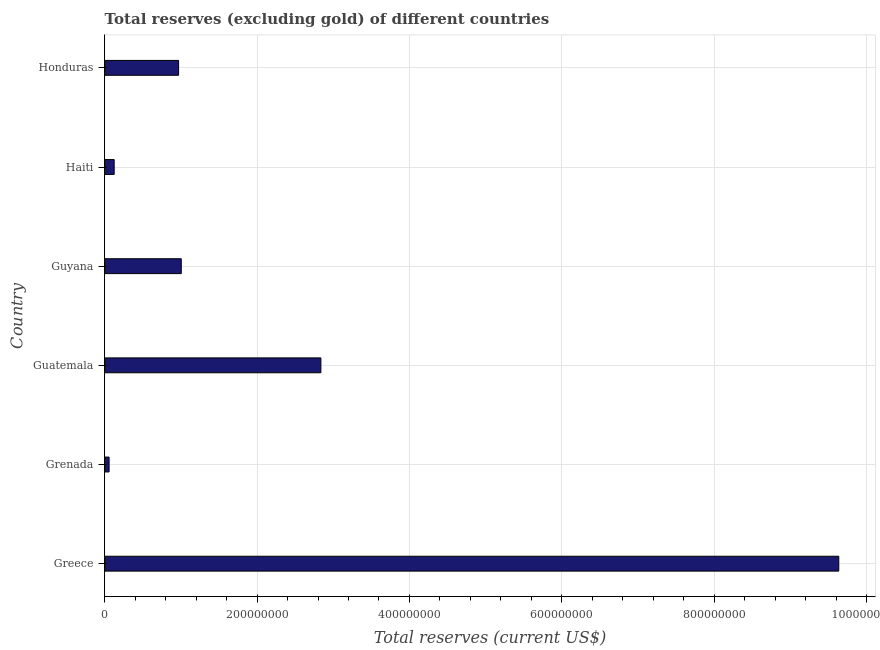Does the graph contain any zero values?
Give a very brief answer. No. Does the graph contain grids?
Make the answer very short. Yes. What is the title of the graph?
Provide a short and direct response. Total reserves (excluding gold) of different countries. What is the label or title of the X-axis?
Your answer should be compact. Total reserves (current US$). What is the total reserves (excluding gold) in Greece?
Your answer should be compact. 9.64e+08. Across all countries, what is the maximum total reserves (excluding gold)?
Make the answer very short. 9.64e+08. Across all countries, what is the minimum total reserves (excluding gold)?
Your response must be concise. 5.75e+06. In which country was the total reserves (excluding gold) maximum?
Your answer should be very brief. Greece. In which country was the total reserves (excluding gold) minimum?
Your answer should be very brief. Grenada. What is the sum of the total reserves (excluding gold)?
Keep it short and to the point. 1.46e+09. What is the difference between the total reserves (excluding gold) in Guyana and Haiti?
Ensure brevity in your answer.  8.81e+07. What is the average total reserves (excluding gold) per country?
Offer a terse response. 2.44e+08. What is the median total reserves (excluding gold)?
Your response must be concise. 9.87e+07. What is the ratio of the total reserves (excluding gold) in Guatemala to that in Guyana?
Ensure brevity in your answer.  2.82. Is the difference between the total reserves (excluding gold) in Greece and Guatemala greater than the difference between any two countries?
Provide a succinct answer. No. What is the difference between the highest and the second highest total reserves (excluding gold)?
Provide a succinct answer. 6.80e+08. What is the difference between the highest and the lowest total reserves (excluding gold)?
Your response must be concise. 9.58e+08. In how many countries, is the total reserves (excluding gold) greater than the average total reserves (excluding gold) taken over all countries?
Give a very brief answer. 2. How many bars are there?
Make the answer very short. 6. Are the values on the major ticks of X-axis written in scientific E-notation?
Offer a terse response. No. What is the Total reserves (current US$) in Greece?
Offer a very short reply. 9.64e+08. What is the Total reserves (current US$) of Grenada?
Give a very brief answer. 5.75e+06. What is the Total reserves (current US$) of Guatemala?
Your answer should be compact. 2.84e+08. What is the Total reserves (current US$) of Guyana?
Ensure brevity in your answer.  1.00e+08. What is the Total reserves (current US$) in Haiti?
Your answer should be compact. 1.24e+07. What is the Total reserves (current US$) of Honduras?
Ensure brevity in your answer.  9.70e+07. What is the difference between the Total reserves (current US$) in Greece and Grenada?
Give a very brief answer. 9.58e+08. What is the difference between the Total reserves (current US$) in Greece and Guatemala?
Your answer should be compact. 6.80e+08. What is the difference between the Total reserves (current US$) in Greece and Guyana?
Provide a succinct answer. 8.63e+08. What is the difference between the Total reserves (current US$) in Greece and Haiti?
Your response must be concise. 9.51e+08. What is the difference between the Total reserves (current US$) in Greece and Honduras?
Keep it short and to the point. 8.67e+08. What is the difference between the Total reserves (current US$) in Grenada and Guatemala?
Ensure brevity in your answer.  -2.78e+08. What is the difference between the Total reserves (current US$) in Grenada and Guyana?
Keep it short and to the point. -9.47e+07. What is the difference between the Total reserves (current US$) in Grenada and Haiti?
Keep it short and to the point. -6.68e+06. What is the difference between the Total reserves (current US$) in Grenada and Honduras?
Provide a succinct answer. -9.12e+07. What is the difference between the Total reserves (current US$) in Guatemala and Guyana?
Give a very brief answer. 1.83e+08. What is the difference between the Total reserves (current US$) in Guatemala and Haiti?
Offer a terse response. 2.71e+08. What is the difference between the Total reserves (current US$) in Guatemala and Honduras?
Provide a short and direct response. 1.87e+08. What is the difference between the Total reserves (current US$) in Guyana and Haiti?
Keep it short and to the point. 8.81e+07. What is the difference between the Total reserves (current US$) in Guyana and Honduras?
Keep it short and to the point. 3.53e+06. What is the difference between the Total reserves (current US$) in Haiti and Honduras?
Provide a succinct answer. -8.45e+07. What is the ratio of the Total reserves (current US$) in Greece to that in Grenada?
Provide a succinct answer. 167.5. What is the ratio of the Total reserves (current US$) in Greece to that in Guatemala?
Give a very brief answer. 3.4. What is the ratio of the Total reserves (current US$) in Greece to that in Guyana?
Your response must be concise. 9.59. What is the ratio of the Total reserves (current US$) in Greece to that in Haiti?
Offer a very short reply. 77.52. What is the ratio of the Total reserves (current US$) in Greece to that in Honduras?
Make the answer very short. 9.94. What is the ratio of the Total reserves (current US$) in Grenada to that in Guyana?
Give a very brief answer. 0.06. What is the ratio of the Total reserves (current US$) in Grenada to that in Haiti?
Offer a terse response. 0.46. What is the ratio of the Total reserves (current US$) in Grenada to that in Honduras?
Keep it short and to the point. 0.06. What is the ratio of the Total reserves (current US$) in Guatemala to that in Guyana?
Your answer should be very brief. 2.82. What is the ratio of the Total reserves (current US$) in Guatemala to that in Haiti?
Make the answer very short. 22.83. What is the ratio of the Total reserves (current US$) in Guatemala to that in Honduras?
Provide a short and direct response. 2.93. What is the ratio of the Total reserves (current US$) in Guyana to that in Haiti?
Keep it short and to the point. 8.09. What is the ratio of the Total reserves (current US$) in Guyana to that in Honduras?
Your response must be concise. 1.04. What is the ratio of the Total reserves (current US$) in Haiti to that in Honduras?
Offer a terse response. 0.13. 